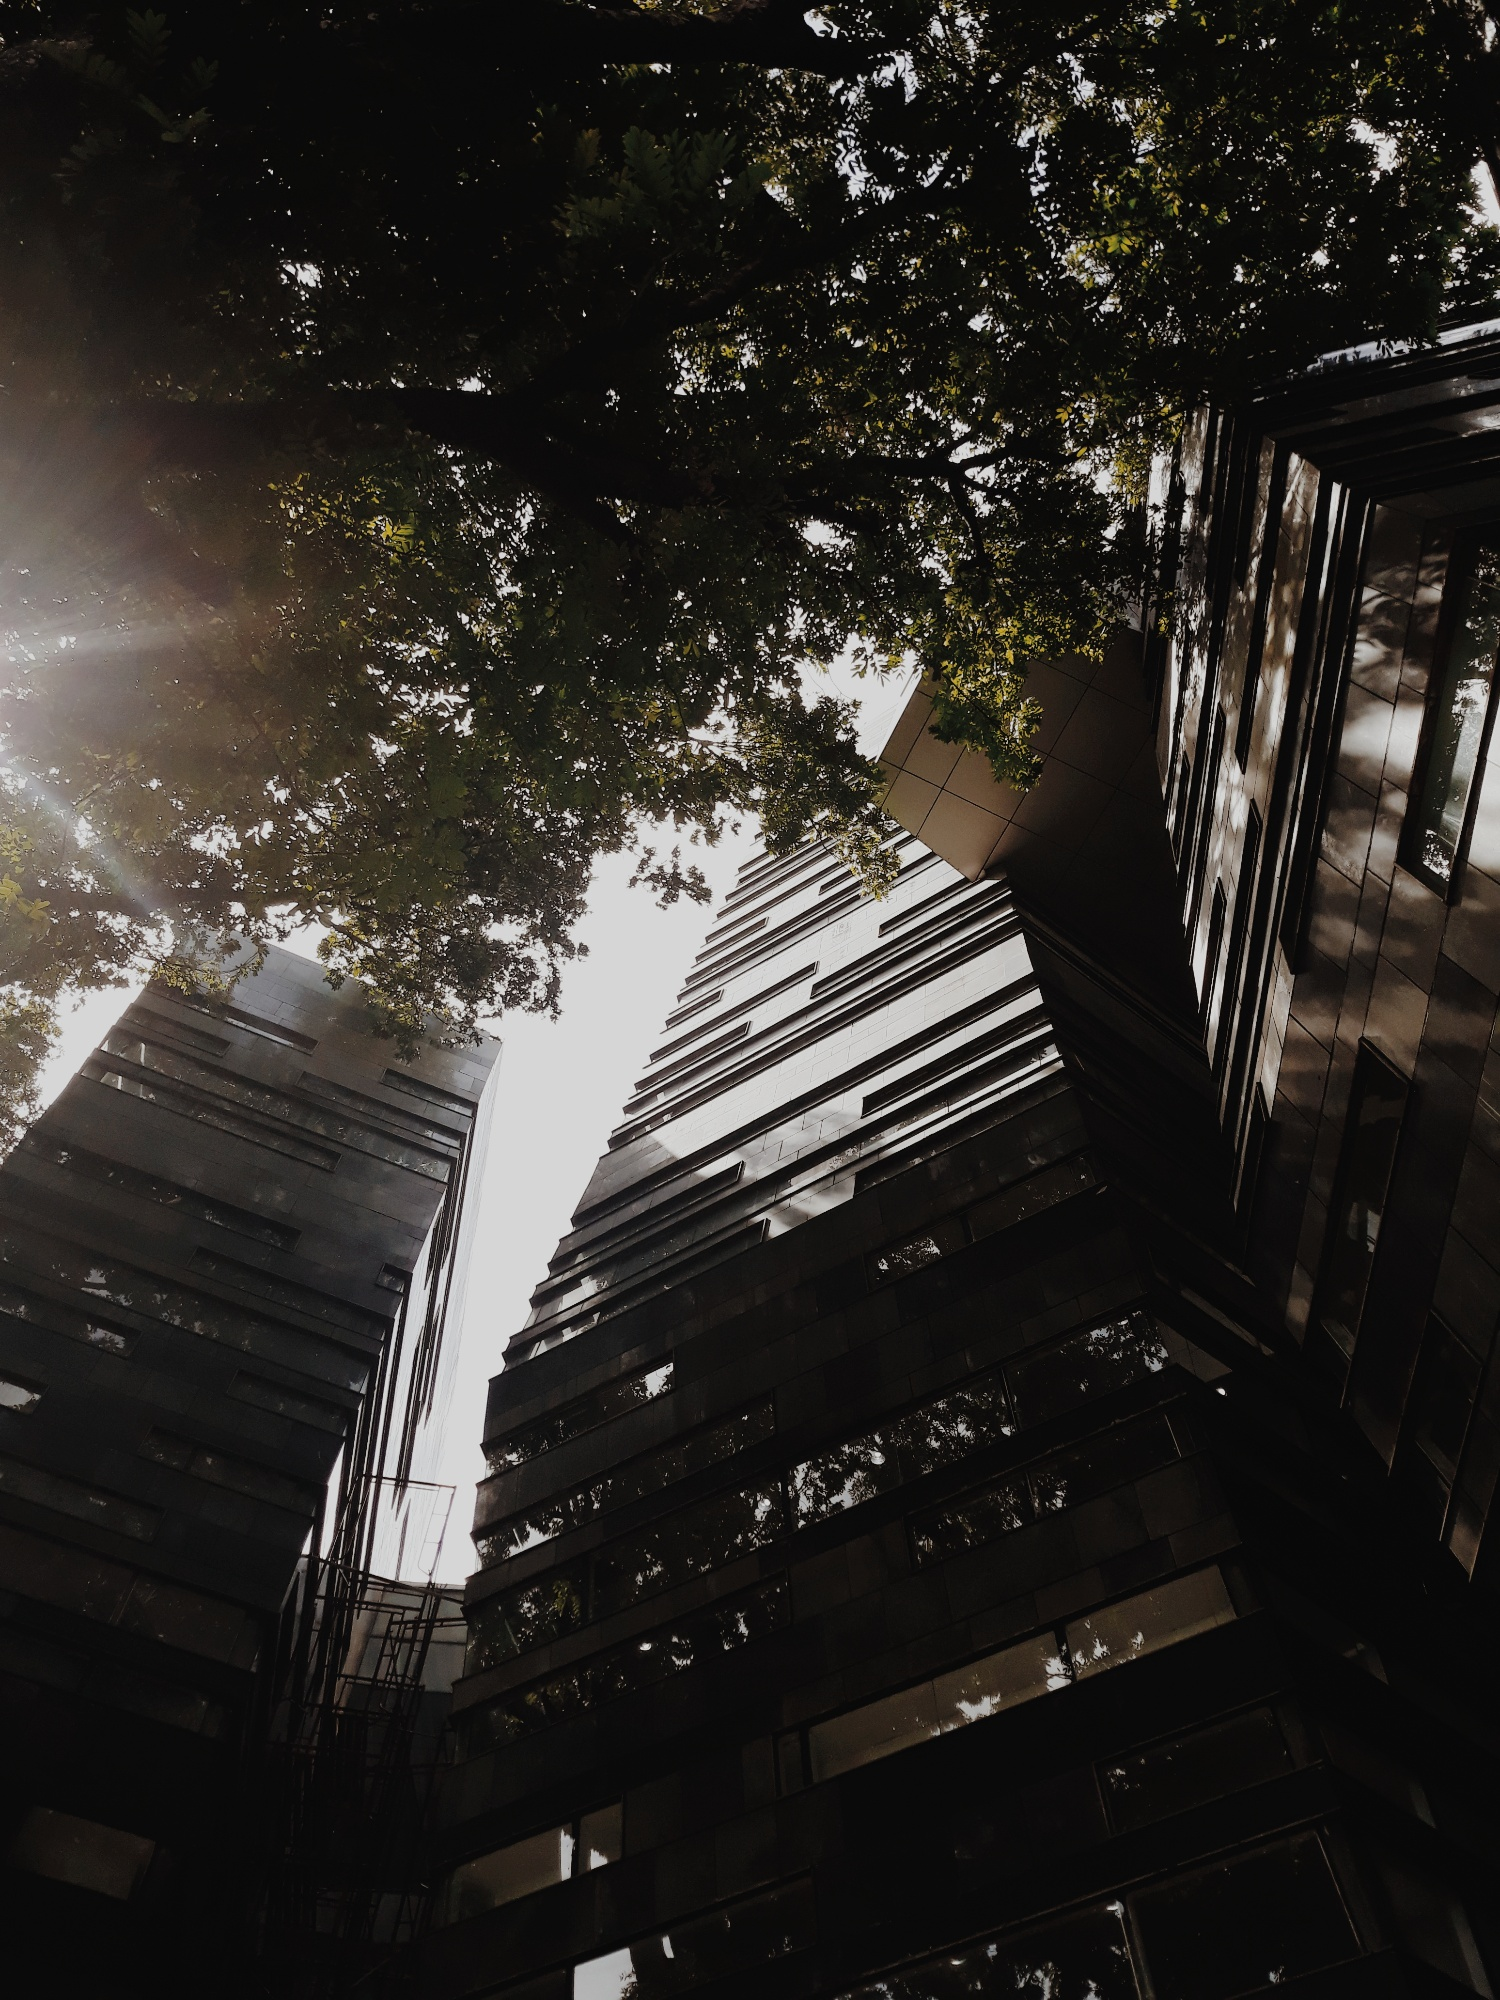How does the interaction between the natural and built environment in the image reflect on urban architectural practices? The image presents a thoughtful integration of the natural environment with contemporary architecture. By allowing the trees to frame the building, there's an emphasis on sustainability and green practices within urban development. This approach not only enhances the aesthetic value of the area but also contributes to improved air quality and reduced urban heat, reflecting an architectural strategy that values environmental considerations alongside structural aesthetics. 